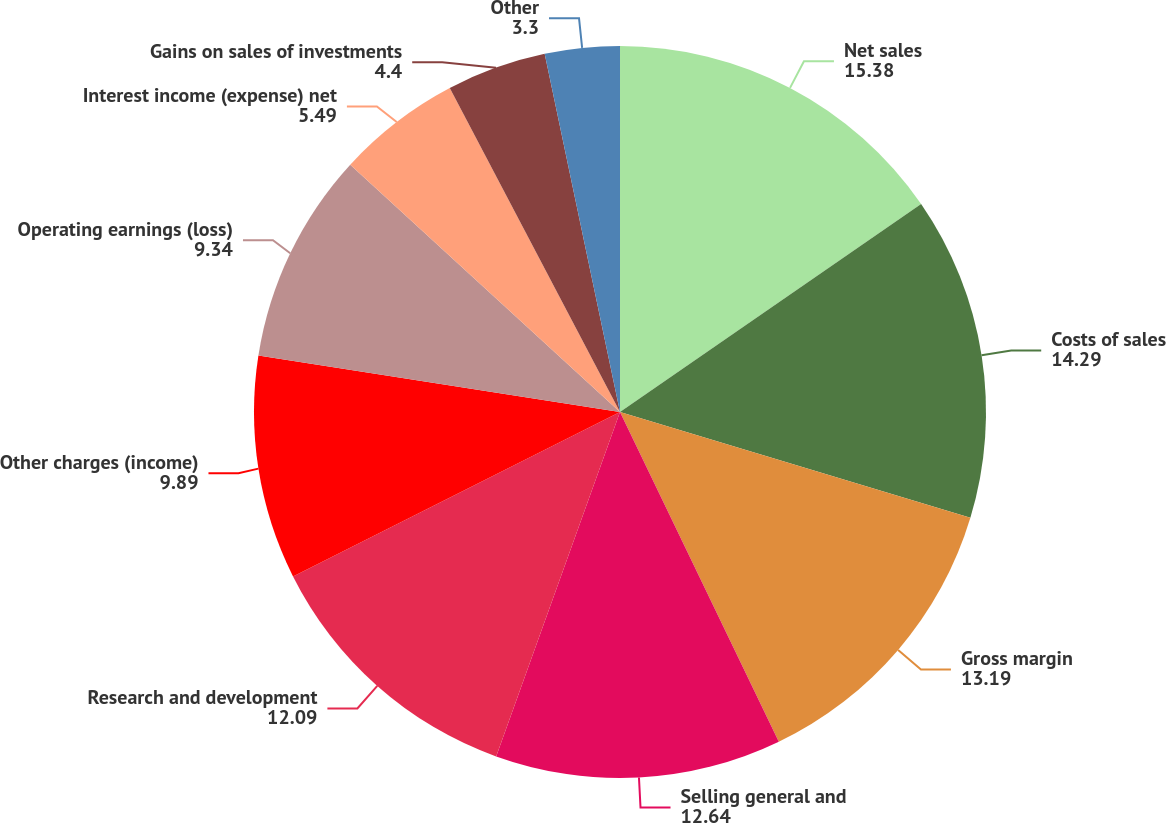Convert chart to OTSL. <chart><loc_0><loc_0><loc_500><loc_500><pie_chart><fcel>Net sales<fcel>Costs of sales<fcel>Gross margin<fcel>Selling general and<fcel>Research and development<fcel>Other charges (income)<fcel>Operating earnings (loss)<fcel>Interest income (expense) net<fcel>Gains on sales of investments<fcel>Other<nl><fcel>15.38%<fcel>14.29%<fcel>13.19%<fcel>12.64%<fcel>12.09%<fcel>9.89%<fcel>9.34%<fcel>5.49%<fcel>4.4%<fcel>3.3%<nl></chart> 